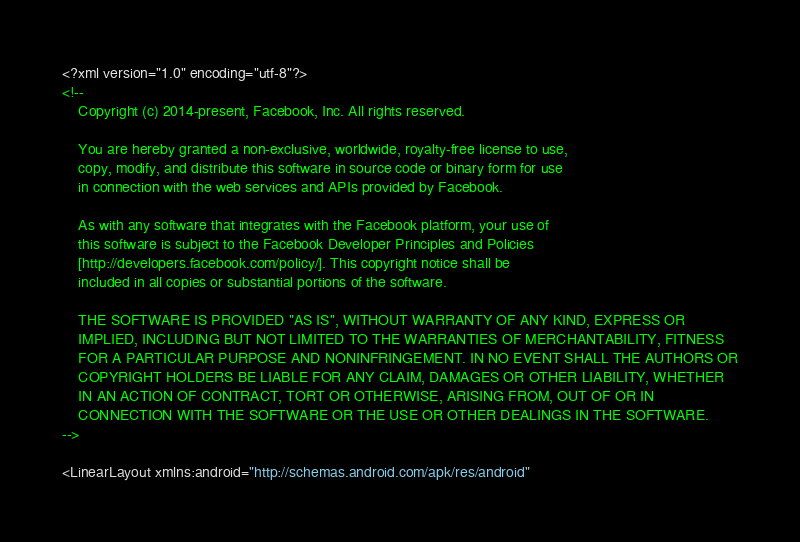<code> <loc_0><loc_0><loc_500><loc_500><_XML_><?xml version="1.0" encoding="utf-8"?>
<!--
	Copyright (c) 2014-present, Facebook, Inc. All rights reserved.

	You are hereby granted a non-exclusive, worldwide, royalty-free license to use,
	copy, modify, and distribute this software in source code or binary form for use
	in connection with the web services and APIs provided by Facebook.

	As with any software that integrates with the Facebook platform, your use of
	this software is subject to the Facebook Developer Principles and Policies
	[http://developers.facebook.com/policy/]. This copyright notice shall be
	included in all copies or substantial portions of the software.

	THE SOFTWARE IS PROVIDED "AS IS", WITHOUT WARRANTY OF ANY KIND, EXPRESS OR
	IMPLIED, INCLUDING BUT NOT LIMITED TO THE WARRANTIES OF MERCHANTABILITY, FITNESS
	FOR A PARTICULAR PURPOSE AND NONINFRINGEMENT. IN NO EVENT SHALL THE AUTHORS OR
	COPYRIGHT HOLDERS BE LIABLE FOR ANY CLAIM, DAMAGES OR OTHER LIABILITY, WHETHER
	IN AN ACTION OF CONTRACT, TORT OR OTHERWISE, ARISING FROM, OUT OF OR IN
	CONNECTION WITH THE SOFTWARE OR THE USE OR OTHER DEALINGS IN THE SOFTWARE.
-->

<LinearLayout xmlns:android="http://schemas.android.com/apk/res/android"</code> 